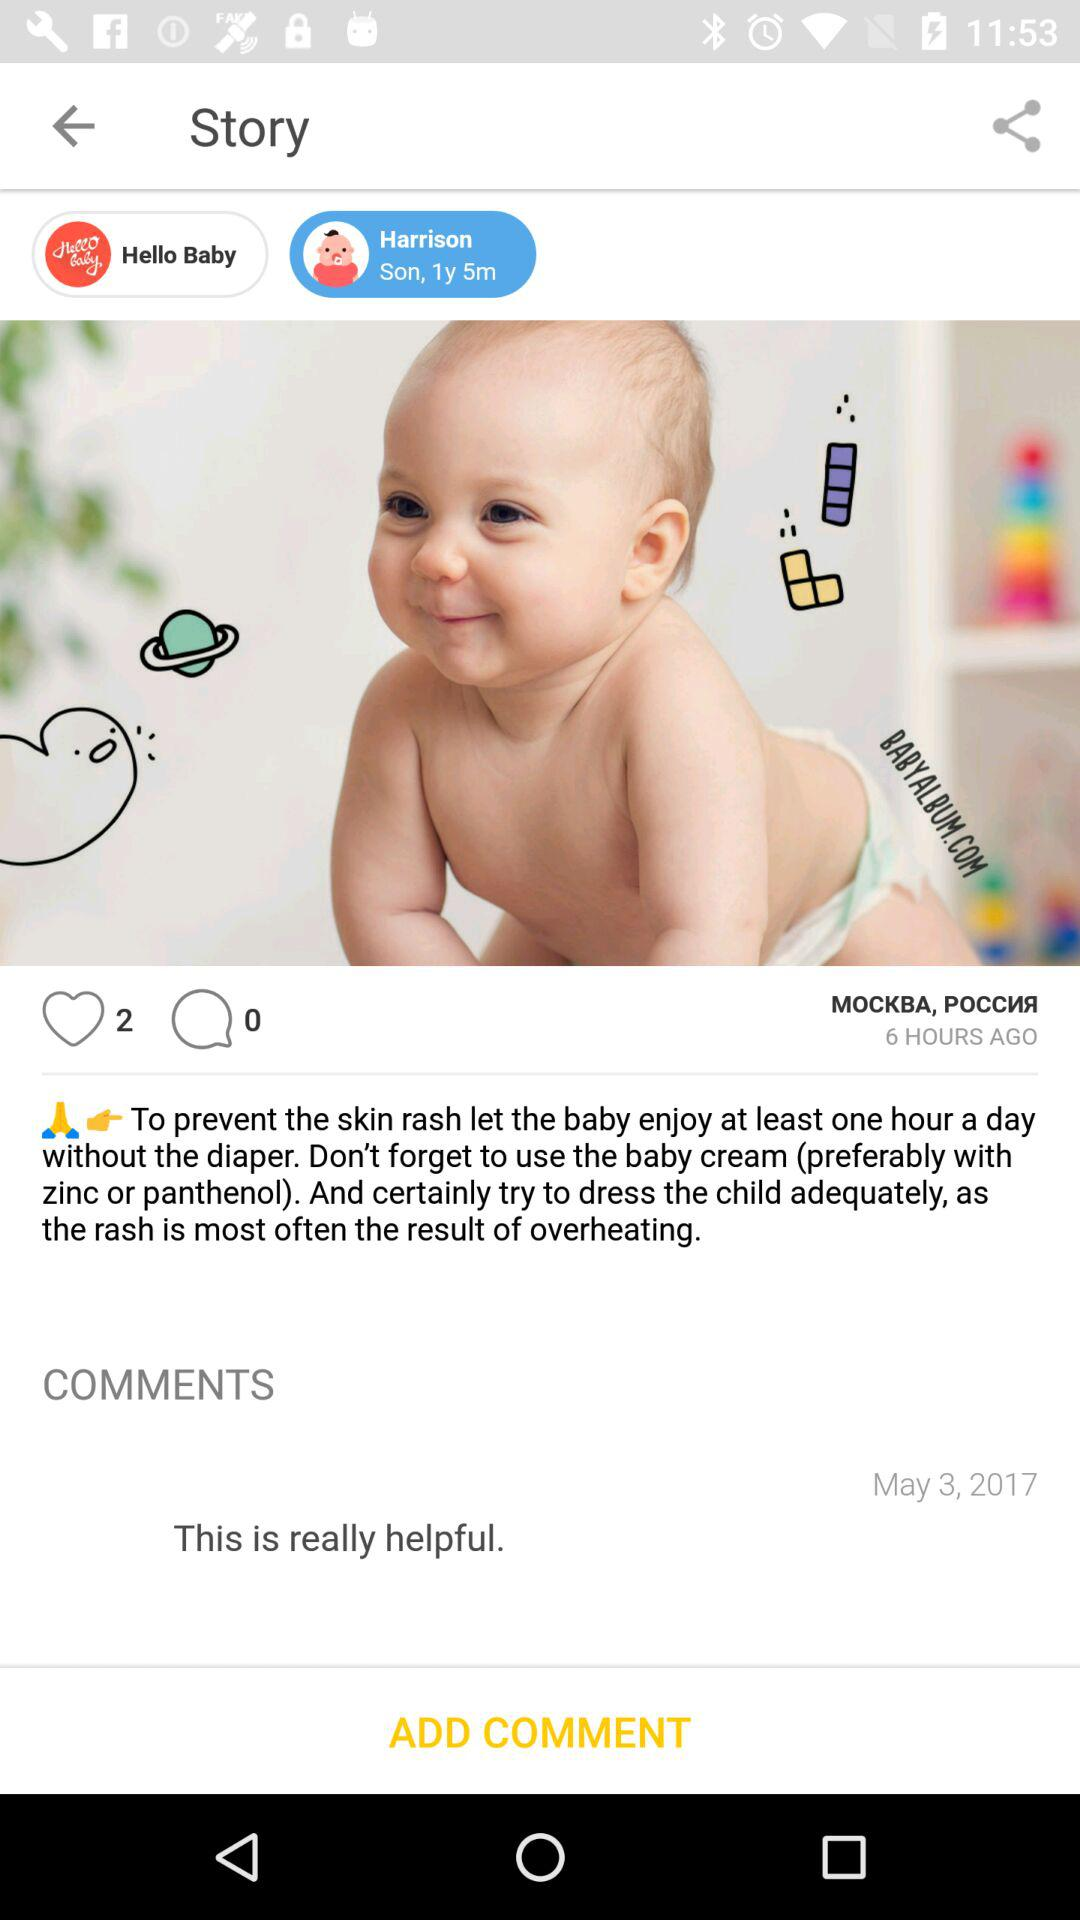How many people liked the post? The post has been liked by 2 people. 